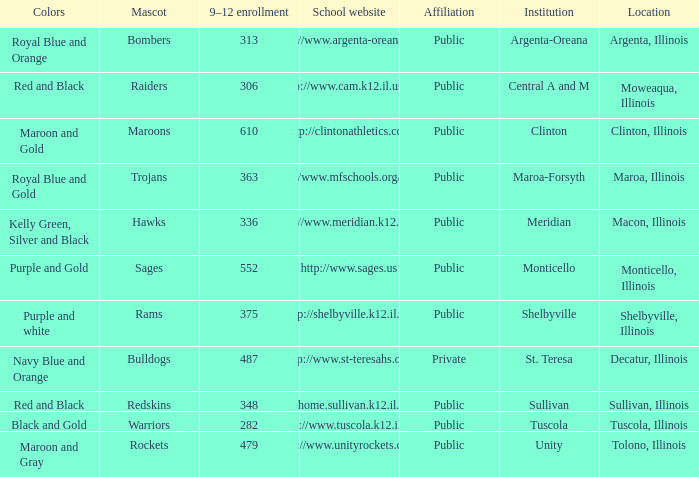What colors can you see players from Tolono, Illinois wearing? Maroon and Gray. Help me parse the entirety of this table. {'header': ['Colors', 'Mascot', '9–12 enrollment', 'School website', 'Affiliation', 'Institution', 'Location'], 'rows': [['Royal Blue and Orange', 'Bombers', '313', 'http://www.argenta-oreana.org', 'Public', 'Argenta-Oreana', 'Argenta, Illinois'], ['Red and Black', 'Raiders', '306', 'http://www.cam.k12.il.us/hs', 'Public', 'Central A and M', 'Moweaqua, Illinois'], ['Maroon and Gold', 'Maroons', '610', 'http://clintonathletics.com', 'Public', 'Clinton', 'Clinton, Illinois'], ['Royal Blue and Gold', 'Trojans', '363', 'http://www.mfschools.org/high/', 'Public', 'Maroa-Forsyth', 'Maroa, Illinois'], ['Kelly Green, Silver and Black', 'Hawks', '336', 'http://www.meridian.k12.il.us/', 'Public', 'Meridian', 'Macon, Illinois'], ['Purple and Gold', 'Sages', '552', 'http://www.sages.us', 'Public', 'Monticello', 'Monticello, Illinois'], ['Purple and white', 'Rams', '375', 'http://shelbyville.k12.il.us/', 'Public', 'Shelbyville', 'Shelbyville, Illinois'], ['Navy Blue and Orange', 'Bulldogs', '487', 'http://www.st-teresahs.org/', 'Private', 'St. Teresa', 'Decatur, Illinois'], ['Red and Black', 'Redskins', '348', 'http://home.sullivan.k12.il.us/shs', 'Public', 'Sullivan', 'Sullivan, Illinois'], ['Black and Gold', 'Warriors', '282', 'http://www.tuscola.k12.il.us/', 'Public', 'Tuscola', 'Tuscola, Illinois'], ['Maroon and Gray', 'Rockets', '479', 'http://www.unityrockets.com/', 'Public', 'Unity', 'Tolono, Illinois']]} 